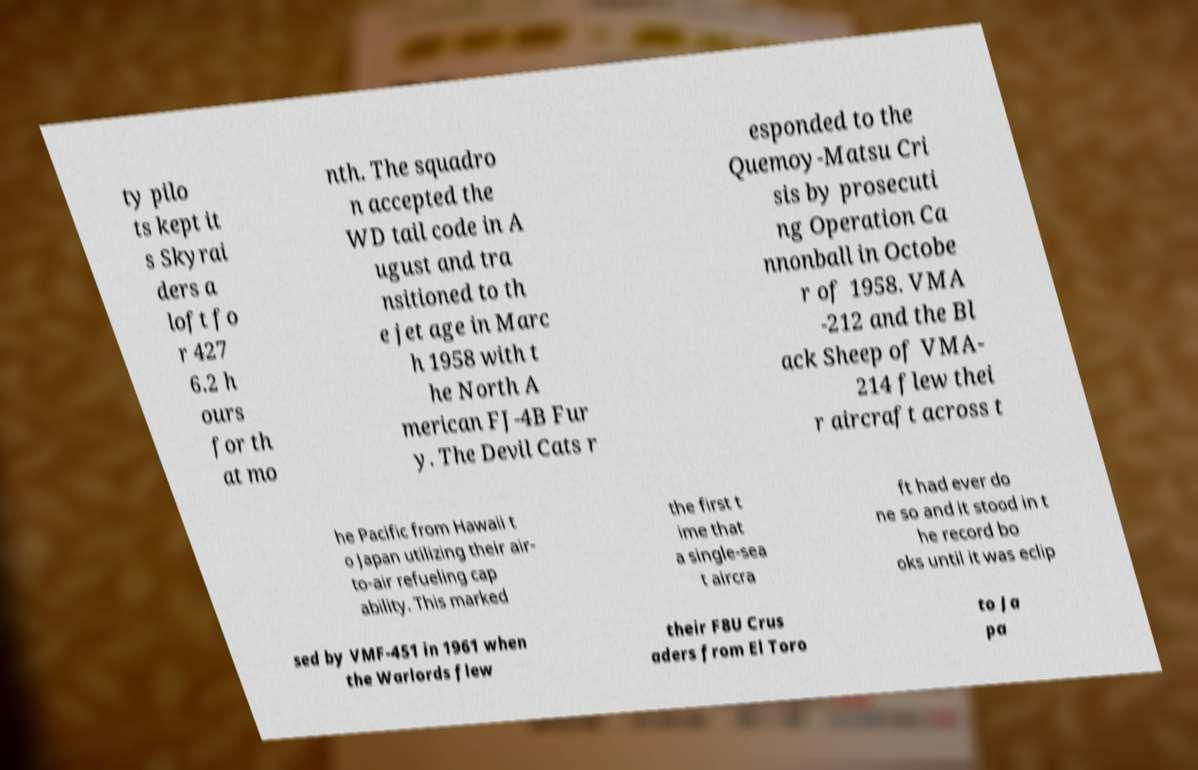I need the written content from this picture converted into text. Can you do that? ty pilo ts kept it s Skyrai ders a loft fo r 427 6.2 h ours for th at mo nth. The squadro n accepted the WD tail code in A ugust and tra nsitioned to th e jet age in Marc h 1958 with t he North A merican FJ-4B Fur y. The Devil Cats r esponded to the Quemoy-Matsu Cri sis by prosecuti ng Operation Ca nnonball in Octobe r of 1958. VMA -212 and the Bl ack Sheep of VMA- 214 flew thei r aircraft across t he Pacific from Hawaii t o Japan utilizing their air- to-air refueling cap ability. This marked the first t ime that a single-sea t aircra ft had ever do ne so and it stood in t he record bo oks until it was eclip sed by VMF-451 in 1961 when the Warlords flew their F8U Crus aders from El Toro to Ja pa 